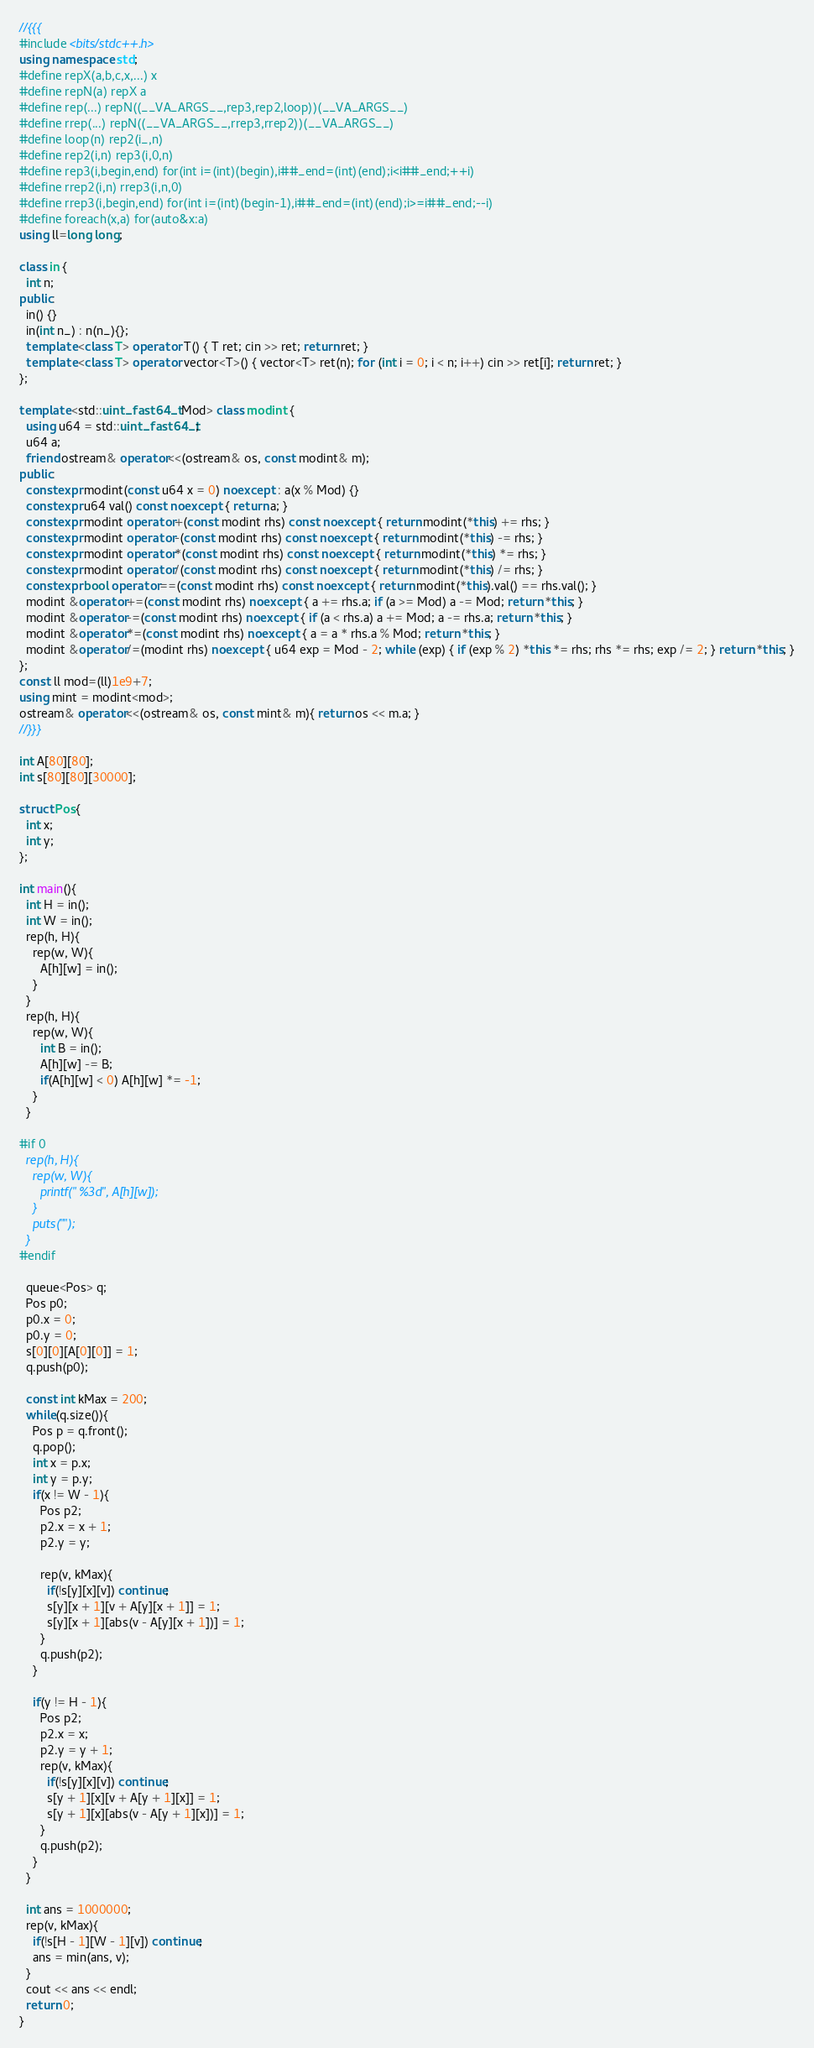Convert code to text. <code><loc_0><loc_0><loc_500><loc_500><_C++_>//{{{
#include <bits/stdc++.h>
using namespace std;
#define repX(a,b,c,x,...) x
#define repN(a) repX a
#define rep(...) repN((__VA_ARGS__,rep3,rep2,loop))(__VA_ARGS__)
#define rrep(...) repN((__VA_ARGS__,rrep3,rrep2))(__VA_ARGS__)
#define loop(n) rep2(i_,n)
#define rep2(i,n) rep3(i,0,n)
#define rep3(i,begin,end) for(int i=(int)(begin),i##_end=(int)(end);i<i##_end;++i)
#define rrep2(i,n) rrep3(i,n,0)
#define rrep3(i,begin,end) for(int i=(int)(begin-1),i##_end=(int)(end);i>=i##_end;--i)
#define foreach(x,a) for(auto&x:a)
using ll=long long;

class in {
  int n;
public:
  in() {}
  in(int n_) : n(n_){};
  template <class T> operator T() { T ret; cin >> ret; return ret; }
  template <class T> operator vector<T>() { vector<T> ret(n); for (int i = 0; i < n; i++) cin >> ret[i]; return ret; }
};

template <std::uint_fast64_t Mod> class modint {
  using u64 = std::uint_fast64_t;
  u64 a;
  friend ostream& operator<<(ostream& os, const modint& m);
public:
  constexpr modint(const u64 x = 0) noexcept : a(x % Mod) {}
  constexpr u64 val() const noexcept { return a; }
  constexpr modint operator+(const modint rhs) const noexcept { return modint(*this) += rhs; }
  constexpr modint operator-(const modint rhs) const noexcept { return modint(*this) -= rhs; }
  constexpr modint operator*(const modint rhs) const noexcept { return modint(*this) *= rhs; }
  constexpr modint operator/(const modint rhs) const noexcept { return modint(*this) /= rhs; }
  constexpr bool operator==(const modint rhs) const noexcept { return modint(*this).val() == rhs.val(); }
  modint &operator+=(const modint rhs) noexcept { a += rhs.a; if (a >= Mod) a -= Mod; return *this; }
  modint &operator-=(const modint rhs) noexcept { if (a < rhs.a) a += Mod; a -= rhs.a; return *this; }
  modint &operator*=(const modint rhs) noexcept { a = a * rhs.a % Mod; return *this; }
  modint &operator/=(modint rhs) noexcept { u64 exp = Mod - 2; while (exp) { if (exp % 2) *this *= rhs; rhs *= rhs; exp /= 2; } return *this; }
};
const ll mod=(ll)1e9+7;
using mint = modint<mod>;
ostream& operator<<(ostream& os, const mint& m){ return os << m.a; }
//}}}

int A[80][80];
int s[80][80][30000];

struct Pos{
  int x;
  int y;
};

int main(){
  int H = in();
  int W = in();
  rep(h, H){
    rep(w, W){
      A[h][w] = in();
    }
  }
  rep(h, H){
    rep(w, W){
      int B = in();
      A[h][w] -= B;
      if(A[h][w] < 0) A[h][w] *= -1;
    }
  }

#if 0
  rep(h, H){
    rep(w, W){
      printf(" %3d", A[h][w]);
    }
    puts("");
  }
#endif

  queue<Pos> q;
  Pos p0;
  p0.x = 0;
  p0.y = 0;
  s[0][0][A[0][0]] = 1;
  q.push(p0);

  const int kMax = 200;
  while(q.size()){
    Pos p = q.front();
    q.pop();
    int x = p.x;
    int y = p.y;
    if(x != W - 1){
      Pos p2;
      p2.x = x + 1;
      p2.y = y;

      rep(v, kMax){
        if(!s[y][x][v]) continue;
        s[y][x + 1][v + A[y][x + 1]] = 1;
        s[y][x + 1][abs(v - A[y][x + 1])] = 1;
      }
      q.push(p2);
    }

    if(y != H - 1){
      Pos p2;
      p2.x = x;
      p2.y = y + 1;
      rep(v, kMax){
        if(!s[y][x][v]) continue;
        s[y + 1][x][v + A[y + 1][x]] = 1;
        s[y + 1][x][abs(v - A[y + 1][x])] = 1;
      }
      q.push(p2);
    }
  }

  int ans = 1000000;
  rep(v, kMax){
    if(!s[H - 1][W - 1][v]) continue;
    ans = min(ans, v);
  }
  cout << ans << endl;
  return 0;
}
</code> 